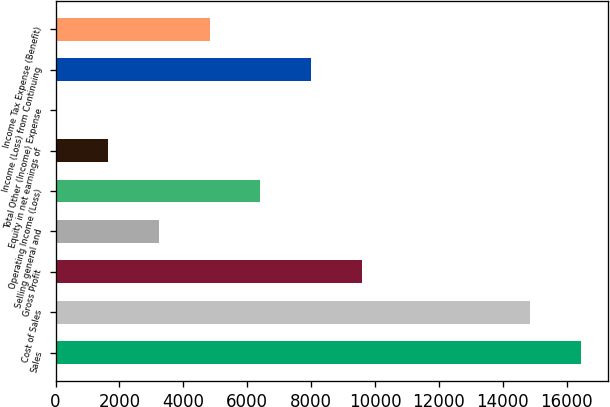<chart> <loc_0><loc_0><loc_500><loc_500><bar_chart><fcel>Sales<fcel>Cost of Sales<fcel>Gross Profit<fcel>Selling general and<fcel>Operating Income (Loss)<fcel>Equity in net earnings of<fcel>Total Other (Income) Expense<fcel>Income (Loss) from Continuing<fcel>Income Tax Expense (Benefit)<nl><fcel>16457.2<fcel>14867<fcel>9589.2<fcel>3228.4<fcel>6408.8<fcel>1638.2<fcel>48<fcel>7999<fcel>4818.6<nl></chart> 